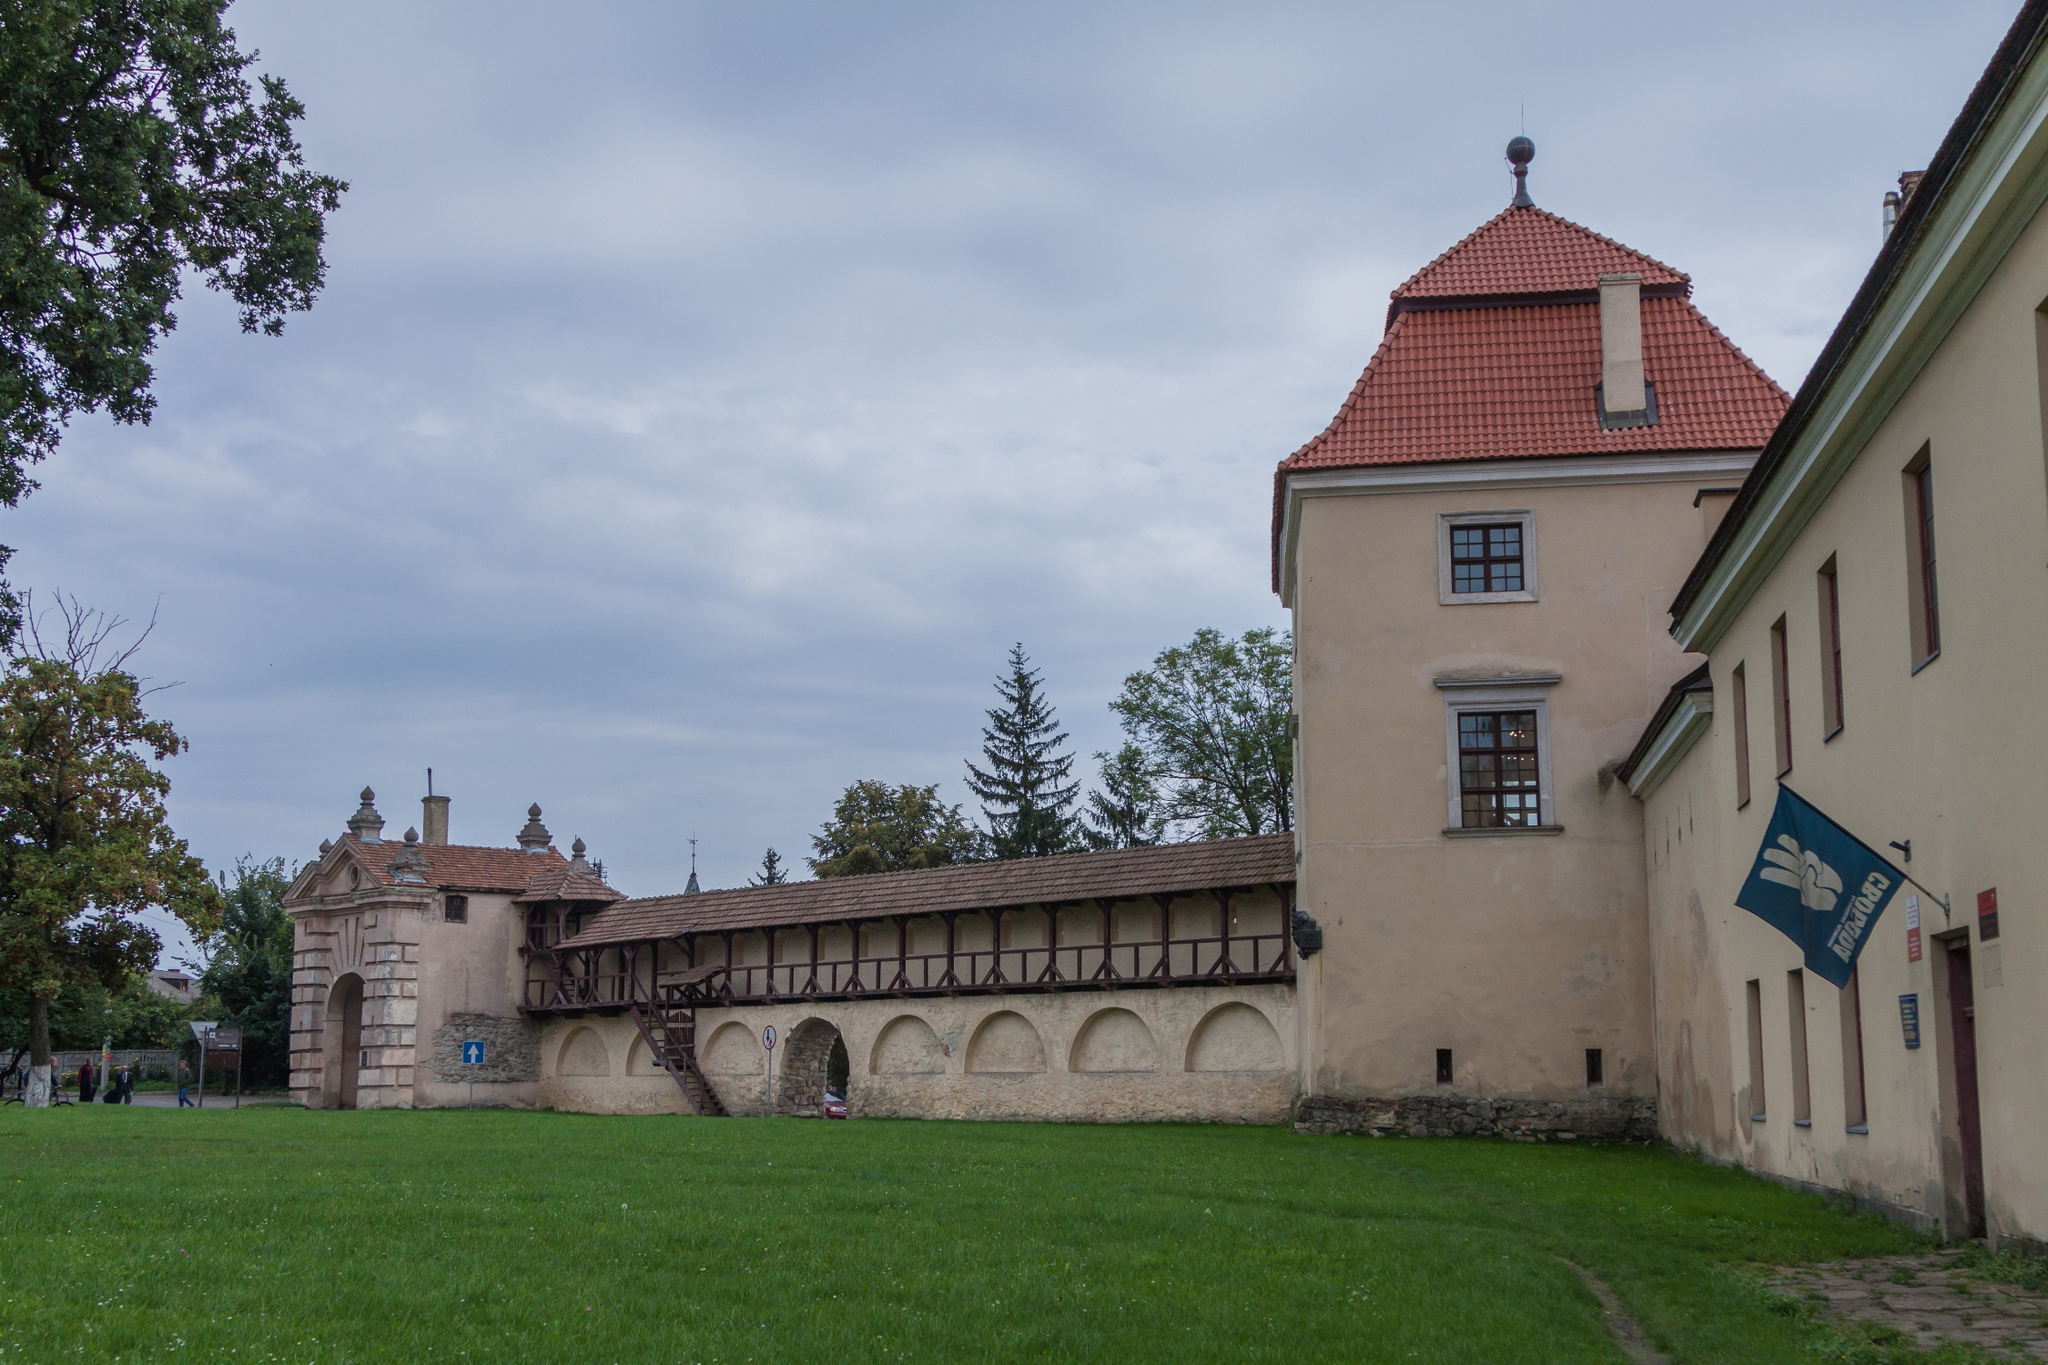What modern uses might this building have if it were repurposed today? If repurposed today, this historic building could serve multiple modern uses while preserving its character and significance. It could be transformed into a museum or cultural center, offering exhibits on local history and art, educational tours, and community events. Alternatively, it might become a boutique hotel or a high-end restaurant, allowing guests to experience the charm of a bygone era with modern amenities. It could also serve as an office space for businesses seeking a unique and inspiring environment. Furthermore, the serene park-like setting makes it ideal for wellness retreats or artist residencies, providing tranquility and inspiration for creativity and relaxation. 